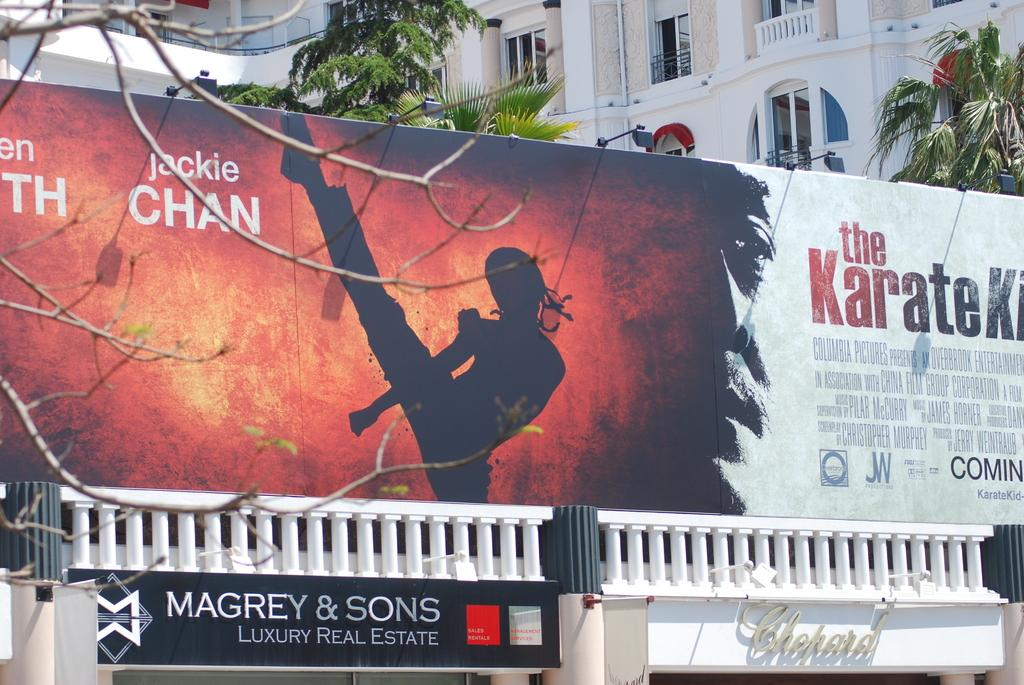What is the main object in the center of the image? There is a board in the center of the image. What can be found at the bottom of the image? There are stores at the bottom of the image. What is visible in the background of the image? There are buildings and trees in the background of the image. How many snails are crawling on the board in the image? There are no snails present in the image; the board is the main object in the center. 